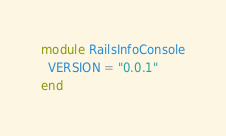<code> <loc_0><loc_0><loc_500><loc_500><_Ruby_>module RailsInfoConsole
  VERSION = "0.0.1"
end
</code> 